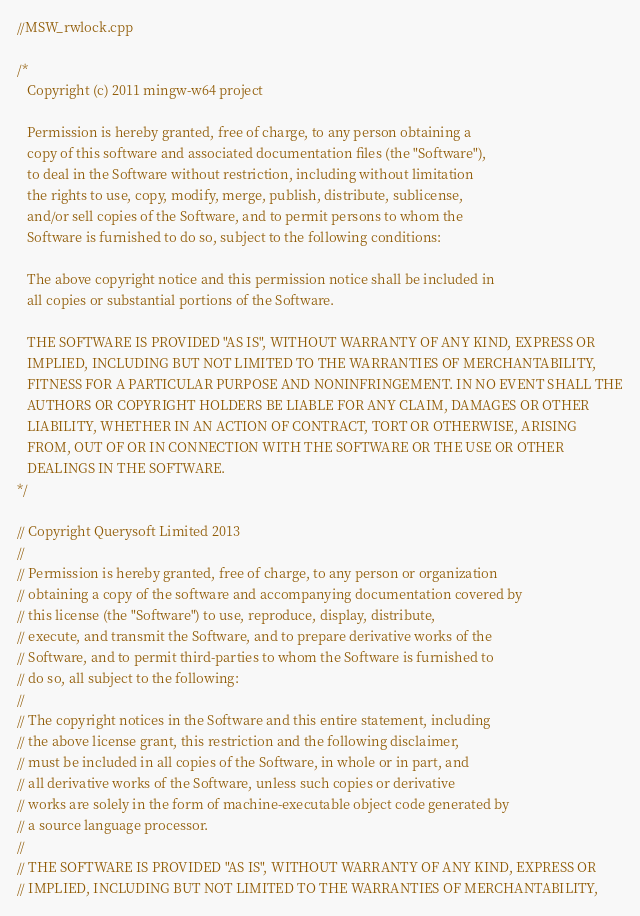<code> <loc_0><loc_0><loc_500><loc_500><_C++_>//MSW_rwlock.cpp

/*
   Copyright (c) 2011 mingw-w64 project

   Permission is hereby granted, free of charge, to any person obtaining a
   copy of this software and associated documentation files (the "Software"),
   to deal in the Software without restriction, including without limitation
   the rights to use, copy, modify, merge, publish, distribute, sublicense,
   and/or sell copies of the Software, and to permit persons to whom the
   Software is furnished to do so, subject to the following conditions:

   The above copyright notice and this permission notice shall be included in
   all copies or substantial portions of the Software.

   THE SOFTWARE IS PROVIDED "AS IS", WITHOUT WARRANTY OF ANY KIND, EXPRESS OR
   IMPLIED, INCLUDING BUT NOT LIMITED TO THE WARRANTIES OF MERCHANTABILITY,
   FITNESS FOR A PARTICULAR PURPOSE AND NONINFRINGEMENT. IN NO EVENT SHALL THE
   AUTHORS OR COPYRIGHT HOLDERS BE LIABLE FOR ANY CLAIM, DAMAGES OR OTHER
   LIABILITY, WHETHER IN AN ACTION OF CONTRACT, TORT OR OTHERWISE, ARISING
   FROM, OUT OF OR IN CONNECTION WITH THE SOFTWARE OR THE USE OR OTHER
   DEALINGS IN THE SOFTWARE.
*/

// Copyright Querysoft Limited 2013
//
// Permission is hereby granted, free of charge, to any person or organization
// obtaining a copy of the software and accompanying documentation covered by
// this license (the "Software") to use, reproduce, display, distribute,
// execute, and transmit the Software, and to prepare derivative works of the
// Software, and to permit third-parties to whom the Software is furnished to
// do so, all subject to the following:
// 
// The copyright notices in the Software and this entire statement, including
// the above license grant, this restriction and the following disclaimer,
// must be included in all copies of the Software, in whole or in part, and
// all derivative works of the Software, unless such copies or derivative
// works are solely in the form of machine-executable object code generated by
// a source language processor.
// 
// THE SOFTWARE IS PROVIDED "AS IS", WITHOUT WARRANTY OF ANY KIND, EXPRESS OR
// IMPLIED, INCLUDING BUT NOT LIMITED TO THE WARRANTIES OF MERCHANTABILITY,</code> 